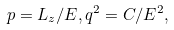<formula> <loc_0><loc_0><loc_500><loc_500>p = L _ { z } / E , q ^ { 2 } = C / E ^ { 2 } ,</formula> 